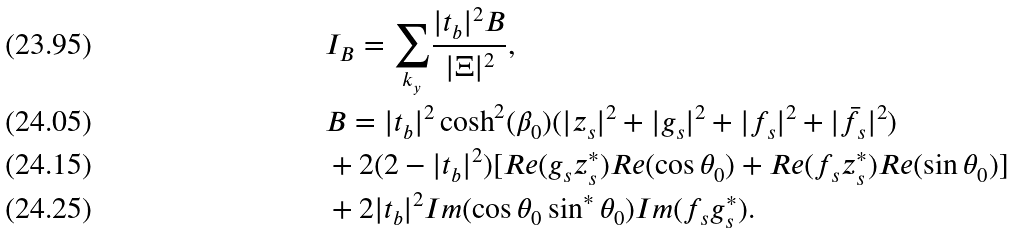<formula> <loc_0><loc_0><loc_500><loc_500>& I _ { B } = { \sum _ { k _ { y } } } \frac { | t _ { b } | ^ { 2 } B } { | \Xi | ^ { 2 } } , \\ & B = | t _ { b } | ^ { 2 } \cosh ^ { 2 } ( \beta _ { 0 } ) ( | z _ { s } | ^ { 2 } + | g _ { s } | ^ { 2 } + | f _ { s } | ^ { 2 } + | \bar { f } _ { s } | ^ { 2 } ) \\ & + 2 ( 2 - | t _ { b } | ^ { 2 } ) [ R e ( g _ { s } z _ { s } ^ { \ast } ) R e ( \cos \theta _ { 0 } ) + R e ( f _ { s } z _ { s } ^ { \ast } ) R e ( \sin \theta _ { 0 } ) ] \\ & + 2 | t _ { b } | ^ { 2 } I m ( \cos \theta _ { 0 } \sin ^ { \ast } \theta _ { 0 } ) I m ( f _ { s } g _ { s } ^ { \ast } ) .</formula> 